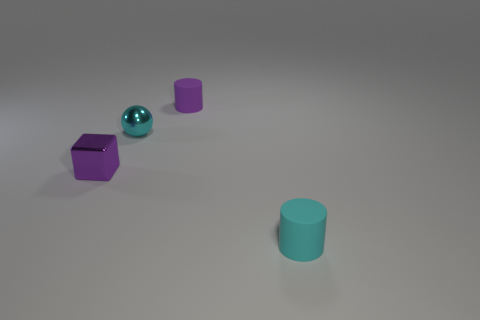There is a small cylinder that is behind the small cyan matte thing; what is its color?
Keep it short and to the point. Purple. The purple metallic object is what shape?
Your answer should be compact. Cube. The tiny purple object behind the small metallic thing in front of the cyan ball is made of what material?
Keep it short and to the point. Rubber. There is another cyan thing that is the same size as the cyan shiny object; what is its material?
Your response must be concise. Rubber. Is the number of rubber objects behind the small purple matte object greater than the number of tiny metallic things left of the tiny shiny block?
Provide a succinct answer. No. Are there any other purple objects of the same shape as the tiny purple matte thing?
Provide a succinct answer. No. There is a cyan metal thing that is the same size as the purple matte object; what shape is it?
Give a very brief answer. Sphere. What shape is the shiny thing that is behind the purple shiny thing?
Keep it short and to the point. Sphere. Is the number of matte objects to the right of the tiny purple rubber cylinder less than the number of small purple rubber things in front of the tiny cyan shiny thing?
Your response must be concise. No. Do the cyan rubber object and the metallic object in front of the cyan shiny sphere have the same size?
Make the answer very short. Yes. 